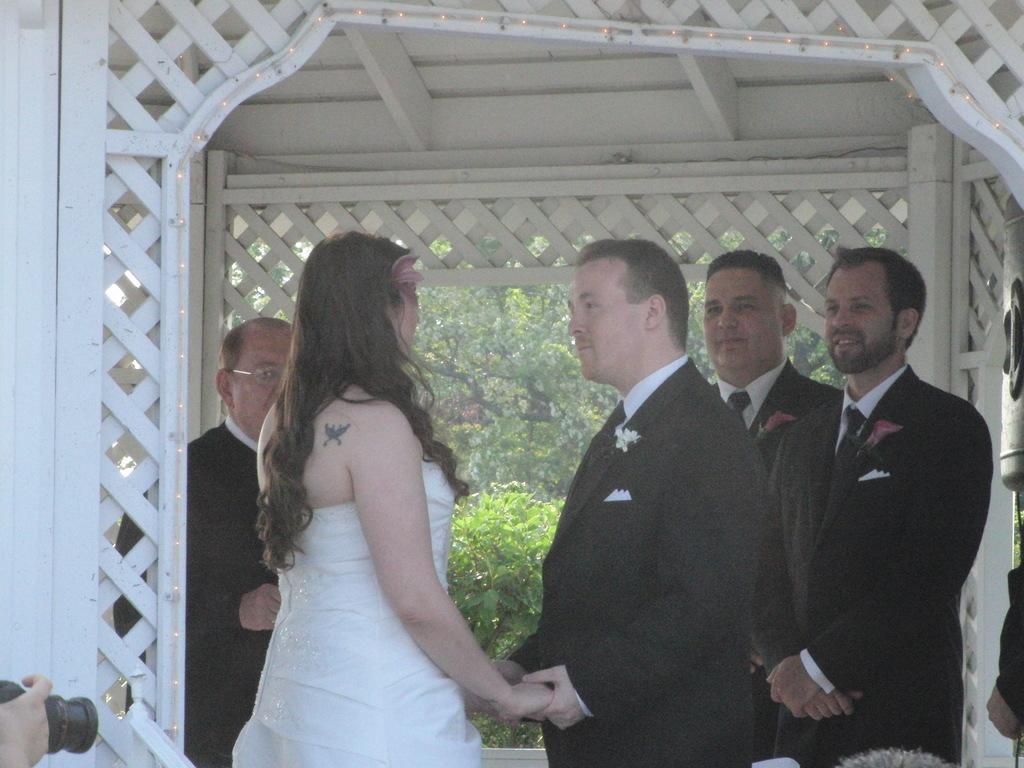Please provide a concise description of this image. In this image there are four men and a woman standing. In the center, the man and the women are holding hands of each other. They are below the shed. Behind them there are trees and hedges. In the bottom left there is a hand of a person holding a camera. 